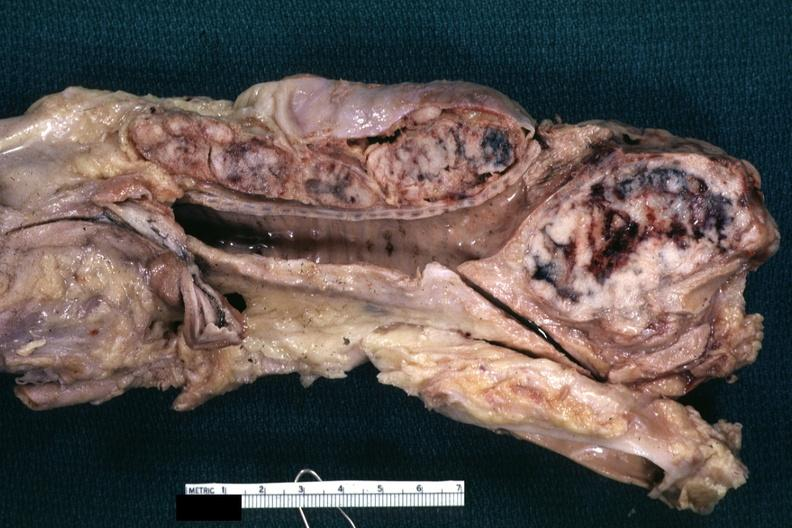what is present?
Answer the question using a single word or phrase. Mediastinal lymph nodes 